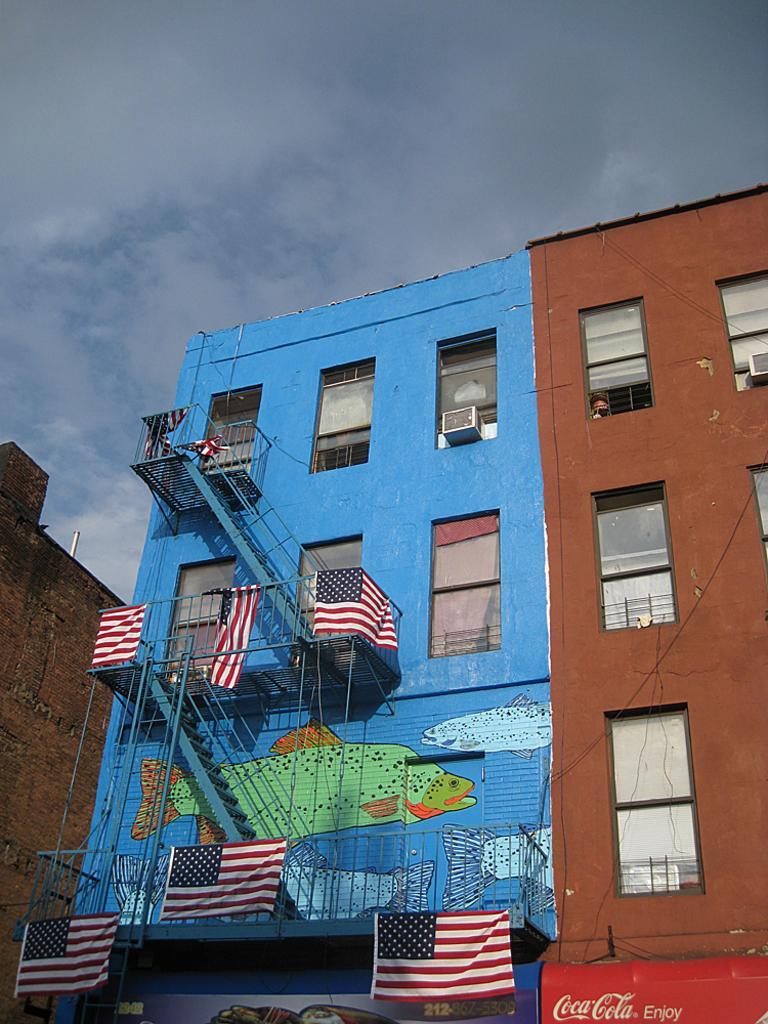Can you describe this image briefly? These are the buildings with the windows. I can see the wall painting on the wall. These are the flags hanging. I can see the stairs. These are the clouds in the sky. 